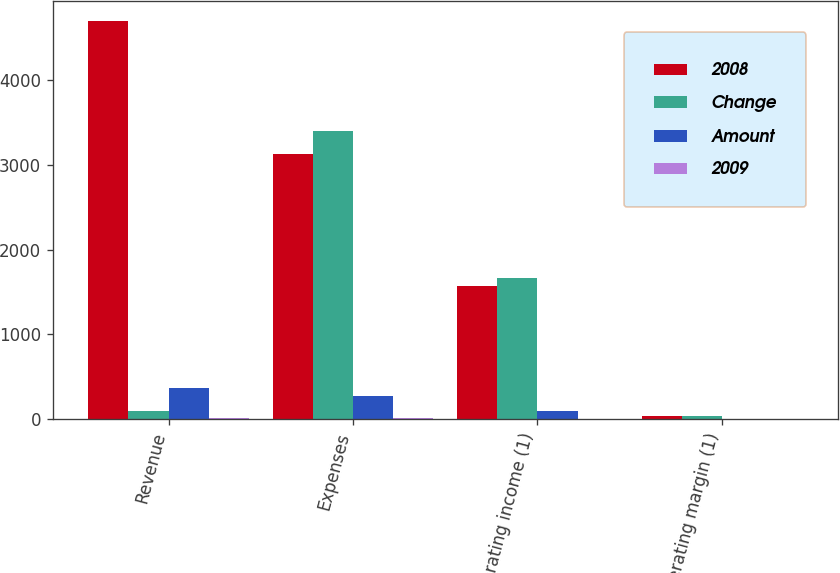Convert chart. <chart><loc_0><loc_0><loc_500><loc_500><stacked_bar_chart><ecel><fcel>Revenue<fcel>Expenses<fcel>Operating income (1)<fcel>Operating margin (1)<nl><fcel>2008<fcel>4700<fcel>3130<fcel>1570<fcel>38.2<nl><fcel>Change<fcel>92<fcel>3402<fcel>1662<fcel>38.7<nl><fcel>Amount<fcel>364<fcel>272<fcel>92<fcel>0.5<nl><fcel>2009<fcel>7<fcel>8<fcel>6<fcel>1<nl></chart> 